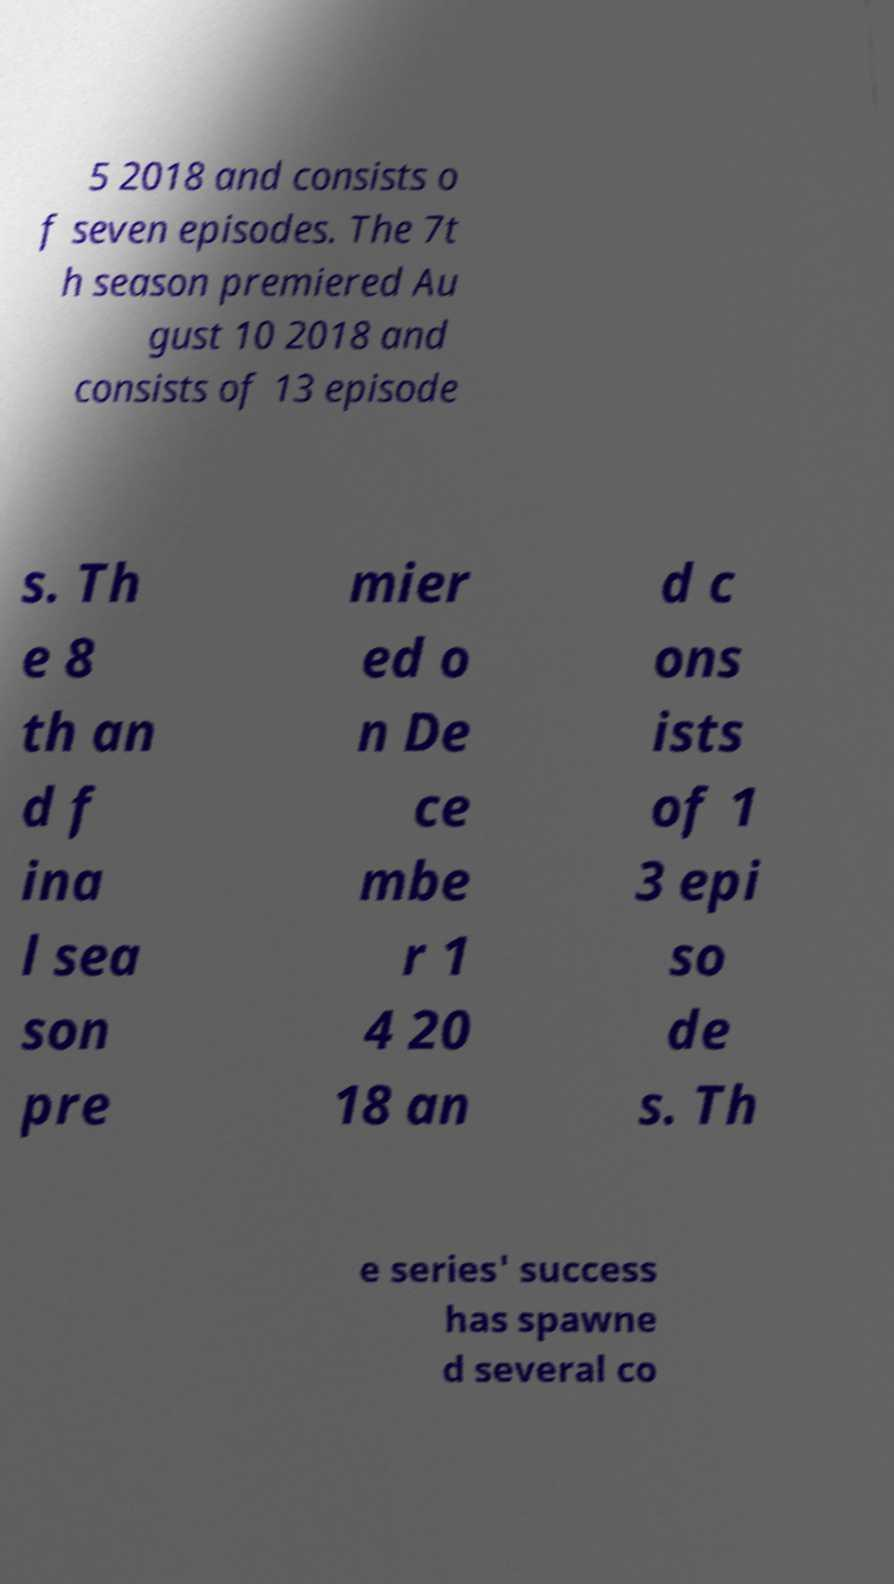Can you accurately transcribe the text from the provided image for me? 5 2018 and consists o f seven episodes. The 7t h season premiered Au gust 10 2018 and consists of 13 episode s. Th e 8 th an d f ina l sea son pre mier ed o n De ce mbe r 1 4 20 18 an d c ons ists of 1 3 epi so de s. Th e series' success has spawne d several co 